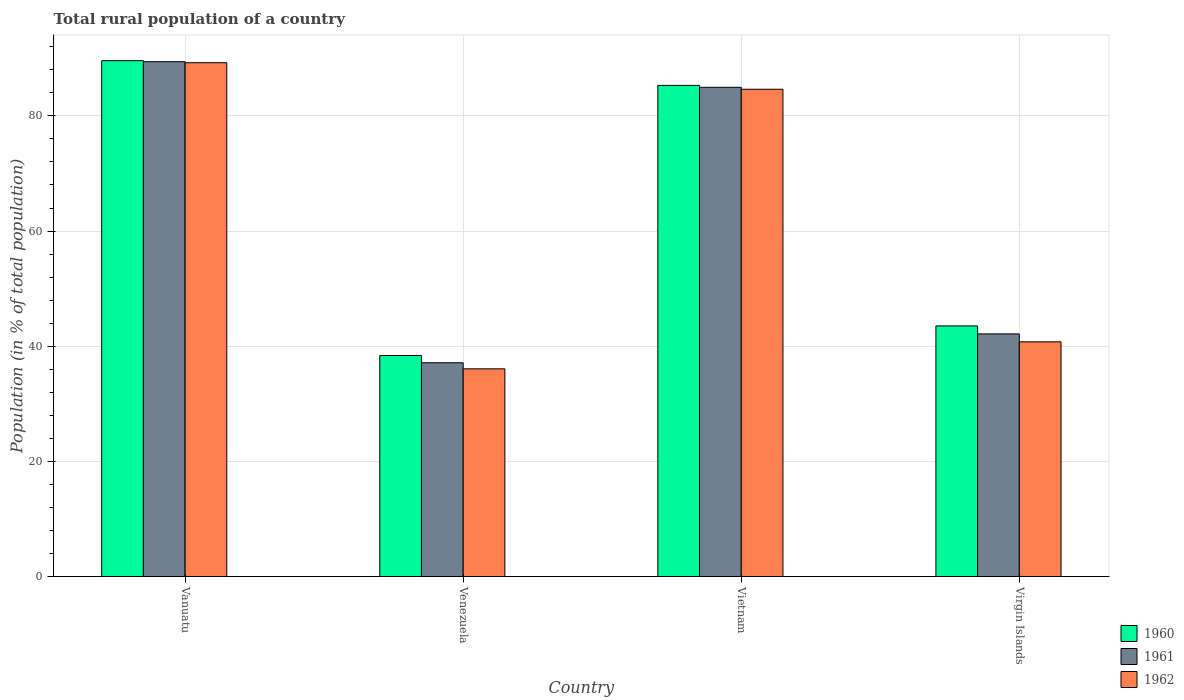How many groups of bars are there?
Ensure brevity in your answer.  4. What is the label of the 3rd group of bars from the left?
Your answer should be very brief. Vietnam. In how many cases, is the number of bars for a given country not equal to the number of legend labels?
Ensure brevity in your answer.  0. What is the rural population in 1960 in Vietnam?
Ensure brevity in your answer.  85.3. Across all countries, what is the maximum rural population in 1962?
Your answer should be very brief. 89.23. Across all countries, what is the minimum rural population in 1961?
Give a very brief answer. 37.12. In which country was the rural population in 1960 maximum?
Offer a very short reply. Vanuatu. In which country was the rural population in 1960 minimum?
Provide a short and direct response. Venezuela. What is the total rural population in 1960 in the graph?
Your answer should be compact. 256.81. What is the difference between the rural population in 1960 in Venezuela and that in Virgin Islands?
Your answer should be very brief. -5.14. What is the difference between the rural population in 1961 in Vietnam and the rural population in 1960 in Virgin Islands?
Offer a very short reply. 41.45. What is the average rural population in 1961 per country?
Provide a succinct answer. 63.41. What is the difference between the rural population of/in 1960 and rural population of/in 1961 in Venezuela?
Your answer should be very brief. 1.26. In how many countries, is the rural population in 1960 greater than 20 %?
Your response must be concise. 4. What is the ratio of the rural population in 1960 in Vanuatu to that in Venezuela?
Keep it short and to the point. 2.33. Is the rural population in 1962 in Venezuela less than that in Vietnam?
Offer a terse response. Yes. What is the difference between the highest and the second highest rural population in 1961?
Your answer should be very brief. 47.28. What is the difference between the highest and the lowest rural population in 1960?
Your answer should be compact. 51.21. In how many countries, is the rural population in 1961 greater than the average rural population in 1961 taken over all countries?
Keep it short and to the point. 2. What does the 1st bar from the left in Virgin Islands represents?
Make the answer very short. 1960. Is it the case that in every country, the sum of the rural population in 1962 and rural population in 1960 is greater than the rural population in 1961?
Your answer should be very brief. Yes. Are all the bars in the graph horizontal?
Your response must be concise. No. What is the difference between two consecutive major ticks on the Y-axis?
Your answer should be compact. 20. Are the values on the major ticks of Y-axis written in scientific E-notation?
Provide a succinct answer. No. Does the graph contain any zero values?
Your answer should be compact. No. How many legend labels are there?
Ensure brevity in your answer.  3. How are the legend labels stacked?
Offer a very short reply. Vertical. What is the title of the graph?
Your response must be concise. Total rural population of a country. Does "1960" appear as one of the legend labels in the graph?
Your answer should be very brief. Yes. What is the label or title of the X-axis?
Offer a terse response. Country. What is the label or title of the Y-axis?
Your answer should be very brief. Population (in % of total population). What is the Population (in % of total population) in 1960 in Vanuatu?
Your answer should be compact. 89.6. What is the Population (in % of total population) of 1961 in Vanuatu?
Give a very brief answer. 89.42. What is the Population (in % of total population) of 1962 in Vanuatu?
Your answer should be compact. 89.23. What is the Population (in % of total population) in 1960 in Venezuela?
Keep it short and to the point. 38.39. What is the Population (in % of total population) in 1961 in Venezuela?
Your answer should be very brief. 37.12. What is the Population (in % of total population) in 1962 in Venezuela?
Provide a succinct answer. 36.07. What is the Population (in % of total population) of 1960 in Vietnam?
Give a very brief answer. 85.3. What is the Population (in % of total population) in 1961 in Vietnam?
Give a very brief answer. 84.97. What is the Population (in % of total population) in 1962 in Vietnam?
Your answer should be very brief. 84.63. What is the Population (in % of total population) of 1960 in Virgin Islands?
Provide a short and direct response. 43.52. What is the Population (in % of total population) in 1961 in Virgin Islands?
Make the answer very short. 42.14. What is the Population (in % of total population) in 1962 in Virgin Islands?
Provide a succinct answer. 40.76. Across all countries, what is the maximum Population (in % of total population) in 1960?
Keep it short and to the point. 89.6. Across all countries, what is the maximum Population (in % of total population) of 1961?
Offer a very short reply. 89.42. Across all countries, what is the maximum Population (in % of total population) of 1962?
Provide a short and direct response. 89.23. Across all countries, what is the minimum Population (in % of total population) of 1960?
Your response must be concise. 38.39. Across all countries, what is the minimum Population (in % of total population) of 1961?
Ensure brevity in your answer.  37.12. Across all countries, what is the minimum Population (in % of total population) in 1962?
Give a very brief answer. 36.07. What is the total Population (in % of total population) of 1960 in the graph?
Keep it short and to the point. 256.81. What is the total Population (in % of total population) in 1961 in the graph?
Offer a very short reply. 253.65. What is the total Population (in % of total population) in 1962 in the graph?
Offer a very short reply. 250.69. What is the difference between the Population (in % of total population) in 1960 in Vanuatu and that in Venezuela?
Ensure brevity in your answer.  51.21. What is the difference between the Population (in % of total population) in 1961 in Vanuatu and that in Venezuela?
Your response must be concise. 52.29. What is the difference between the Population (in % of total population) of 1962 in Vanuatu and that in Venezuela?
Ensure brevity in your answer.  53.17. What is the difference between the Population (in % of total population) in 1960 in Vanuatu and that in Vietnam?
Make the answer very short. 4.3. What is the difference between the Population (in % of total population) of 1961 in Vanuatu and that in Vietnam?
Keep it short and to the point. 4.45. What is the difference between the Population (in % of total population) in 1962 in Vanuatu and that in Vietnam?
Keep it short and to the point. 4.6. What is the difference between the Population (in % of total population) in 1960 in Vanuatu and that in Virgin Islands?
Your response must be concise. 46.07. What is the difference between the Population (in % of total population) in 1961 in Vanuatu and that in Virgin Islands?
Your response must be concise. 47.28. What is the difference between the Population (in % of total population) of 1962 in Vanuatu and that in Virgin Islands?
Offer a very short reply. 48.48. What is the difference between the Population (in % of total population) in 1960 in Venezuela and that in Vietnam?
Offer a very short reply. -46.91. What is the difference between the Population (in % of total population) in 1961 in Venezuela and that in Vietnam?
Provide a succinct answer. -47.84. What is the difference between the Population (in % of total population) of 1962 in Venezuela and that in Vietnam?
Your answer should be very brief. -48.56. What is the difference between the Population (in % of total population) in 1960 in Venezuela and that in Virgin Islands?
Your response must be concise. -5.14. What is the difference between the Population (in % of total population) in 1961 in Venezuela and that in Virgin Islands?
Your answer should be compact. -5.01. What is the difference between the Population (in % of total population) of 1962 in Venezuela and that in Virgin Islands?
Offer a terse response. -4.69. What is the difference between the Population (in % of total population) in 1960 in Vietnam and that in Virgin Islands?
Provide a short and direct response. 41.78. What is the difference between the Population (in % of total population) in 1961 in Vietnam and that in Virgin Islands?
Your answer should be very brief. 42.83. What is the difference between the Population (in % of total population) of 1962 in Vietnam and that in Virgin Islands?
Your response must be concise. 43.87. What is the difference between the Population (in % of total population) of 1960 in Vanuatu and the Population (in % of total population) of 1961 in Venezuela?
Your response must be concise. 52.47. What is the difference between the Population (in % of total population) of 1960 in Vanuatu and the Population (in % of total population) of 1962 in Venezuela?
Provide a succinct answer. 53.53. What is the difference between the Population (in % of total population) of 1961 in Vanuatu and the Population (in % of total population) of 1962 in Venezuela?
Give a very brief answer. 53.35. What is the difference between the Population (in % of total population) in 1960 in Vanuatu and the Population (in % of total population) in 1961 in Vietnam?
Provide a succinct answer. 4.63. What is the difference between the Population (in % of total population) of 1960 in Vanuatu and the Population (in % of total population) of 1962 in Vietnam?
Your answer should be very brief. 4.96. What is the difference between the Population (in % of total population) of 1961 in Vanuatu and the Population (in % of total population) of 1962 in Vietnam?
Offer a terse response. 4.79. What is the difference between the Population (in % of total population) in 1960 in Vanuatu and the Population (in % of total population) in 1961 in Virgin Islands?
Offer a terse response. 47.46. What is the difference between the Population (in % of total population) in 1960 in Vanuatu and the Population (in % of total population) in 1962 in Virgin Islands?
Provide a short and direct response. 48.84. What is the difference between the Population (in % of total population) of 1961 in Vanuatu and the Population (in % of total population) of 1962 in Virgin Islands?
Your answer should be very brief. 48.66. What is the difference between the Population (in % of total population) in 1960 in Venezuela and the Population (in % of total population) in 1961 in Vietnam?
Make the answer very short. -46.58. What is the difference between the Population (in % of total population) in 1960 in Venezuela and the Population (in % of total population) in 1962 in Vietnam?
Offer a terse response. -46.24. What is the difference between the Population (in % of total population) in 1961 in Venezuela and the Population (in % of total population) in 1962 in Vietnam?
Keep it short and to the point. -47.51. What is the difference between the Population (in % of total population) in 1960 in Venezuela and the Population (in % of total population) in 1961 in Virgin Islands?
Ensure brevity in your answer.  -3.75. What is the difference between the Population (in % of total population) in 1960 in Venezuela and the Population (in % of total population) in 1962 in Virgin Islands?
Ensure brevity in your answer.  -2.37. What is the difference between the Population (in % of total population) in 1961 in Venezuela and the Population (in % of total population) in 1962 in Virgin Islands?
Your answer should be compact. -3.63. What is the difference between the Population (in % of total population) of 1960 in Vietnam and the Population (in % of total population) of 1961 in Virgin Islands?
Offer a terse response. 43.16. What is the difference between the Population (in % of total population) of 1960 in Vietnam and the Population (in % of total population) of 1962 in Virgin Islands?
Provide a short and direct response. 44.54. What is the difference between the Population (in % of total population) in 1961 in Vietnam and the Population (in % of total population) in 1962 in Virgin Islands?
Provide a short and direct response. 44.21. What is the average Population (in % of total population) in 1960 per country?
Give a very brief answer. 64.2. What is the average Population (in % of total population) in 1961 per country?
Offer a terse response. 63.41. What is the average Population (in % of total population) of 1962 per country?
Offer a terse response. 62.67. What is the difference between the Population (in % of total population) of 1960 and Population (in % of total population) of 1961 in Vanuatu?
Your answer should be compact. 0.18. What is the difference between the Population (in % of total population) of 1960 and Population (in % of total population) of 1962 in Vanuatu?
Offer a very short reply. 0.36. What is the difference between the Population (in % of total population) in 1961 and Population (in % of total population) in 1962 in Vanuatu?
Your answer should be compact. 0.18. What is the difference between the Population (in % of total population) in 1960 and Population (in % of total population) in 1961 in Venezuela?
Your response must be concise. 1.26. What is the difference between the Population (in % of total population) in 1960 and Population (in % of total population) in 1962 in Venezuela?
Your response must be concise. 2.32. What is the difference between the Population (in % of total population) of 1961 and Population (in % of total population) of 1962 in Venezuela?
Make the answer very short. 1.06. What is the difference between the Population (in % of total population) in 1960 and Population (in % of total population) in 1961 in Vietnam?
Ensure brevity in your answer.  0.33. What is the difference between the Population (in % of total population) of 1960 and Population (in % of total population) of 1962 in Vietnam?
Ensure brevity in your answer.  0.67. What is the difference between the Population (in % of total population) in 1961 and Population (in % of total population) in 1962 in Vietnam?
Make the answer very short. 0.34. What is the difference between the Population (in % of total population) of 1960 and Population (in % of total population) of 1961 in Virgin Islands?
Provide a succinct answer. 1.39. What is the difference between the Population (in % of total population) of 1960 and Population (in % of total population) of 1962 in Virgin Islands?
Ensure brevity in your answer.  2.76. What is the difference between the Population (in % of total population) in 1961 and Population (in % of total population) in 1962 in Virgin Islands?
Provide a succinct answer. 1.38. What is the ratio of the Population (in % of total population) of 1960 in Vanuatu to that in Venezuela?
Offer a very short reply. 2.33. What is the ratio of the Population (in % of total population) of 1961 in Vanuatu to that in Venezuela?
Provide a short and direct response. 2.41. What is the ratio of the Population (in % of total population) in 1962 in Vanuatu to that in Venezuela?
Provide a short and direct response. 2.47. What is the ratio of the Population (in % of total population) of 1960 in Vanuatu to that in Vietnam?
Your response must be concise. 1.05. What is the ratio of the Population (in % of total population) of 1961 in Vanuatu to that in Vietnam?
Offer a very short reply. 1.05. What is the ratio of the Population (in % of total population) of 1962 in Vanuatu to that in Vietnam?
Keep it short and to the point. 1.05. What is the ratio of the Population (in % of total population) of 1960 in Vanuatu to that in Virgin Islands?
Your response must be concise. 2.06. What is the ratio of the Population (in % of total population) in 1961 in Vanuatu to that in Virgin Islands?
Offer a very short reply. 2.12. What is the ratio of the Population (in % of total population) of 1962 in Vanuatu to that in Virgin Islands?
Keep it short and to the point. 2.19. What is the ratio of the Population (in % of total population) in 1960 in Venezuela to that in Vietnam?
Offer a terse response. 0.45. What is the ratio of the Population (in % of total population) in 1961 in Venezuela to that in Vietnam?
Make the answer very short. 0.44. What is the ratio of the Population (in % of total population) in 1962 in Venezuela to that in Vietnam?
Ensure brevity in your answer.  0.43. What is the ratio of the Population (in % of total population) in 1960 in Venezuela to that in Virgin Islands?
Offer a terse response. 0.88. What is the ratio of the Population (in % of total population) in 1961 in Venezuela to that in Virgin Islands?
Ensure brevity in your answer.  0.88. What is the ratio of the Population (in % of total population) of 1962 in Venezuela to that in Virgin Islands?
Your response must be concise. 0.88. What is the ratio of the Population (in % of total population) in 1960 in Vietnam to that in Virgin Islands?
Your answer should be compact. 1.96. What is the ratio of the Population (in % of total population) of 1961 in Vietnam to that in Virgin Islands?
Your response must be concise. 2.02. What is the ratio of the Population (in % of total population) in 1962 in Vietnam to that in Virgin Islands?
Your answer should be compact. 2.08. What is the difference between the highest and the second highest Population (in % of total population) of 1960?
Give a very brief answer. 4.3. What is the difference between the highest and the second highest Population (in % of total population) in 1961?
Ensure brevity in your answer.  4.45. What is the difference between the highest and the second highest Population (in % of total population) of 1962?
Ensure brevity in your answer.  4.6. What is the difference between the highest and the lowest Population (in % of total population) in 1960?
Provide a succinct answer. 51.21. What is the difference between the highest and the lowest Population (in % of total population) in 1961?
Give a very brief answer. 52.29. What is the difference between the highest and the lowest Population (in % of total population) of 1962?
Offer a very short reply. 53.17. 